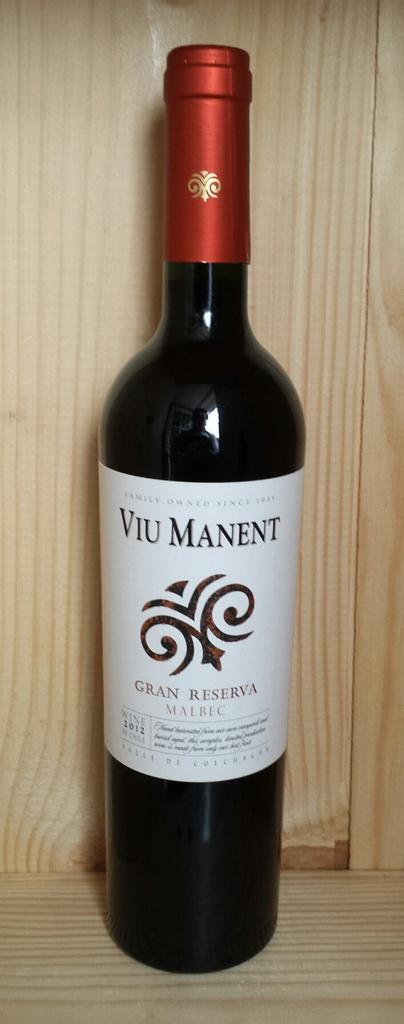<image>
Describe the image concisely. an alcohol bottle with VIU MANENT on the label. 